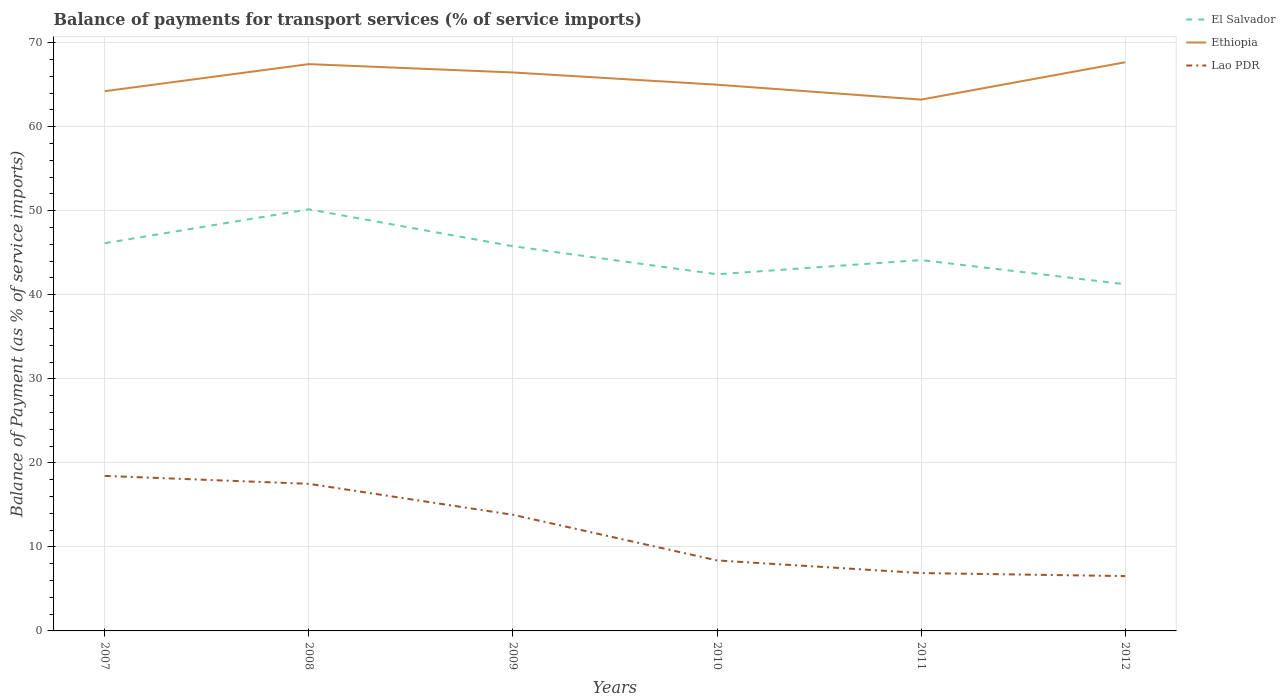How many different coloured lines are there?
Keep it short and to the point. 3. Is the number of lines equal to the number of legend labels?
Your answer should be compact. Yes. Across all years, what is the maximum balance of payments for transport services in Ethiopia?
Ensure brevity in your answer.  63.23. In which year was the balance of payments for transport services in El Salvador maximum?
Your response must be concise. 2012. What is the total balance of payments for transport services in Ethiopia in the graph?
Your answer should be compact. -3.22. What is the difference between the highest and the second highest balance of payments for transport services in Lao PDR?
Provide a succinct answer. 11.92. What is the difference between the highest and the lowest balance of payments for transport services in Lao PDR?
Your response must be concise. 3. How many years are there in the graph?
Your answer should be very brief. 6. Are the values on the major ticks of Y-axis written in scientific E-notation?
Make the answer very short. No. Does the graph contain any zero values?
Keep it short and to the point. No. What is the title of the graph?
Give a very brief answer. Balance of payments for transport services (% of service imports). What is the label or title of the Y-axis?
Provide a succinct answer. Balance of Payment (as % of service imports). What is the Balance of Payment (as % of service imports) in El Salvador in 2007?
Make the answer very short. 46.14. What is the Balance of Payment (as % of service imports) of Ethiopia in 2007?
Give a very brief answer. 64.23. What is the Balance of Payment (as % of service imports) of Lao PDR in 2007?
Give a very brief answer. 18.45. What is the Balance of Payment (as % of service imports) in El Salvador in 2008?
Provide a short and direct response. 50.17. What is the Balance of Payment (as % of service imports) of Ethiopia in 2008?
Your response must be concise. 67.45. What is the Balance of Payment (as % of service imports) in Lao PDR in 2008?
Your answer should be compact. 17.51. What is the Balance of Payment (as % of service imports) in El Salvador in 2009?
Give a very brief answer. 45.78. What is the Balance of Payment (as % of service imports) of Ethiopia in 2009?
Make the answer very short. 66.46. What is the Balance of Payment (as % of service imports) of Lao PDR in 2009?
Your answer should be very brief. 13.82. What is the Balance of Payment (as % of service imports) in El Salvador in 2010?
Keep it short and to the point. 42.44. What is the Balance of Payment (as % of service imports) of Ethiopia in 2010?
Provide a short and direct response. 65. What is the Balance of Payment (as % of service imports) in Lao PDR in 2010?
Your answer should be very brief. 8.39. What is the Balance of Payment (as % of service imports) of El Salvador in 2011?
Your answer should be very brief. 44.13. What is the Balance of Payment (as % of service imports) of Ethiopia in 2011?
Make the answer very short. 63.23. What is the Balance of Payment (as % of service imports) in Lao PDR in 2011?
Your answer should be compact. 6.89. What is the Balance of Payment (as % of service imports) in El Salvador in 2012?
Ensure brevity in your answer.  41.25. What is the Balance of Payment (as % of service imports) of Ethiopia in 2012?
Give a very brief answer. 67.67. What is the Balance of Payment (as % of service imports) of Lao PDR in 2012?
Offer a very short reply. 6.53. Across all years, what is the maximum Balance of Payment (as % of service imports) in El Salvador?
Ensure brevity in your answer.  50.17. Across all years, what is the maximum Balance of Payment (as % of service imports) in Ethiopia?
Make the answer very short. 67.67. Across all years, what is the maximum Balance of Payment (as % of service imports) in Lao PDR?
Make the answer very short. 18.45. Across all years, what is the minimum Balance of Payment (as % of service imports) in El Salvador?
Ensure brevity in your answer.  41.25. Across all years, what is the minimum Balance of Payment (as % of service imports) of Ethiopia?
Keep it short and to the point. 63.23. Across all years, what is the minimum Balance of Payment (as % of service imports) in Lao PDR?
Your response must be concise. 6.53. What is the total Balance of Payment (as % of service imports) in El Salvador in the graph?
Your answer should be compact. 269.92. What is the total Balance of Payment (as % of service imports) in Ethiopia in the graph?
Your answer should be compact. 394.03. What is the total Balance of Payment (as % of service imports) in Lao PDR in the graph?
Your answer should be compact. 71.57. What is the difference between the Balance of Payment (as % of service imports) in El Salvador in 2007 and that in 2008?
Ensure brevity in your answer.  -4.03. What is the difference between the Balance of Payment (as % of service imports) in Ethiopia in 2007 and that in 2008?
Make the answer very short. -3.22. What is the difference between the Balance of Payment (as % of service imports) of Lao PDR in 2007 and that in 2008?
Keep it short and to the point. 0.94. What is the difference between the Balance of Payment (as % of service imports) in El Salvador in 2007 and that in 2009?
Keep it short and to the point. 0.36. What is the difference between the Balance of Payment (as % of service imports) of Ethiopia in 2007 and that in 2009?
Provide a succinct answer. -2.23. What is the difference between the Balance of Payment (as % of service imports) in Lao PDR in 2007 and that in 2009?
Your response must be concise. 4.63. What is the difference between the Balance of Payment (as % of service imports) of El Salvador in 2007 and that in 2010?
Offer a very short reply. 3.69. What is the difference between the Balance of Payment (as % of service imports) of Ethiopia in 2007 and that in 2010?
Your response must be concise. -0.77. What is the difference between the Balance of Payment (as % of service imports) in Lao PDR in 2007 and that in 2010?
Keep it short and to the point. 10.06. What is the difference between the Balance of Payment (as % of service imports) in El Salvador in 2007 and that in 2011?
Keep it short and to the point. 2.01. What is the difference between the Balance of Payment (as % of service imports) in Lao PDR in 2007 and that in 2011?
Your response must be concise. 11.56. What is the difference between the Balance of Payment (as % of service imports) of El Salvador in 2007 and that in 2012?
Your response must be concise. 4.88. What is the difference between the Balance of Payment (as % of service imports) in Ethiopia in 2007 and that in 2012?
Your response must be concise. -3.44. What is the difference between the Balance of Payment (as % of service imports) of Lao PDR in 2007 and that in 2012?
Provide a short and direct response. 11.92. What is the difference between the Balance of Payment (as % of service imports) in El Salvador in 2008 and that in 2009?
Provide a short and direct response. 4.39. What is the difference between the Balance of Payment (as % of service imports) of Lao PDR in 2008 and that in 2009?
Ensure brevity in your answer.  3.69. What is the difference between the Balance of Payment (as % of service imports) in El Salvador in 2008 and that in 2010?
Offer a very short reply. 7.73. What is the difference between the Balance of Payment (as % of service imports) in Ethiopia in 2008 and that in 2010?
Offer a terse response. 2.45. What is the difference between the Balance of Payment (as % of service imports) of Lao PDR in 2008 and that in 2010?
Offer a very short reply. 9.12. What is the difference between the Balance of Payment (as % of service imports) of El Salvador in 2008 and that in 2011?
Offer a very short reply. 6.04. What is the difference between the Balance of Payment (as % of service imports) of Ethiopia in 2008 and that in 2011?
Offer a terse response. 4.22. What is the difference between the Balance of Payment (as % of service imports) of Lao PDR in 2008 and that in 2011?
Your answer should be compact. 10.62. What is the difference between the Balance of Payment (as % of service imports) of El Salvador in 2008 and that in 2012?
Offer a very short reply. 8.92. What is the difference between the Balance of Payment (as % of service imports) of Ethiopia in 2008 and that in 2012?
Make the answer very short. -0.22. What is the difference between the Balance of Payment (as % of service imports) in Lao PDR in 2008 and that in 2012?
Your answer should be very brief. 10.98. What is the difference between the Balance of Payment (as % of service imports) in El Salvador in 2009 and that in 2010?
Offer a very short reply. 3.33. What is the difference between the Balance of Payment (as % of service imports) of Ethiopia in 2009 and that in 2010?
Ensure brevity in your answer.  1.46. What is the difference between the Balance of Payment (as % of service imports) of Lao PDR in 2009 and that in 2010?
Keep it short and to the point. 5.43. What is the difference between the Balance of Payment (as % of service imports) in El Salvador in 2009 and that in 2011?
Keep it short and to the point. 1.65. What is the difference between the Balance of Payment (as % of service imports) in Ethiopia in 2009 and that in 2011?
Provide a succinct answer. 3.23. What is the difference between the Balance of Payment (as % of service imports) in Lao PDR in 2009 and that in 2011?
Your answer should be very brief. 6.93. What is the difference between the Balance of Payment (as % of service imports) of El Salvador in 2009 and that in 2012?
Your response must be concise. 4.53. What is the difference between the Balance of Payment (as % of service imports) of Ethiopia in 2009 and that in 2012?
Make the answer very short. -1.21. What is the difference between the Balance of Payment (as % of service imports) of Lao PDR in 2009 and that in 2012?
Ensure brevity in your answer.  7.29. What is the difference between the Balance of Payment (as % of service imports) of El Salvador in 2010 and that in 2011?
Ensure brevity in your answer.  -1.69. What is the difference between the Balance of Payment (as % of service imports) in Ethiopia in 2010 and that in 2011?
Make the answer very short. 1.77. What is the difference between the Balance of Payment (as % of service imports) of Lao PDR in 2010 and that in 2011?
Offer a very short reply. 1.5. What is the difference between the Balance of Payment (as % of service imports) in El Salvador in 2010 and that in 2012?
Your response must be concise. 1.19. What is the difference between the Balance of Payment (as % of service imports) of Ethiopia in 2010 and that in 2012?
Offer a terse response. -2.67. What is the difference between the Balance of Payment (as % of service imports) of Lao PDR in 2010 and that in 2012?
Offer a very short reply. 1.86. What is the difference between the Balance of Payment (as % of service imports) of El Salvador in 2011 and that in 2012?
Give a very brief answer. 2.88. What is the difference between the Balance of Payment (as % of service imports) in Ethiopia in 2011 and that in 2012?
Keep it short and to the point. -4.44. What is the difference between the Balance of Payment (as % of service imports) of Lao PDR in 2011 and that in 2012?
Make the answer very short. 0.36. What is the difference between the Balance of Payment (as % of service imports) of El Salvador in 2007 and the Balance of Payment (as % of service imports) of Ethiopia in 2008?
Give a very brief answer. -21.31. What is the difference between the Balance of Payment (as % of service imports) in El Salvador in 2007 and the Balance of Payment (as % of service imports) in Lao PDR in 2008?
Make the answer very short. 28.63. What is the difference between the Balance of Payment (as % of service imports) of Ethiopia in 2007 and the Balance of Payment (as % of service imports) of Lao PDR in 2008?
Keep it short and to the point. 46.73. What is the difference between the Balance of Payment (as % of service imports) in El Salvador in 2007 and the Balance of Payment (as % of service imports) in Ethiopia in 2009?
Give a very brief answer. -20.32. What is the difference between the Balance of Payment (as % of service imports) in El Salvador in 2007 and the Balance of Payment (as % of service imports) in Lao PDR in 2009?
Your response must be concise. 32.32. What is the difference between the Balance of Payment (as % of service imports) of Ethiopia in 2007 and the Balance of Payment (as % of service imports) of Lao PDR in 2009?
Keep it short and to the point. 50.41. What is the difference between the Balance of Payment (as % of service imports) of El Salvador in 2007 and the Balance of Payment (as % of service imports) of Ethiopia in 2010?
Give a very brief answer. -18.86. What is the difference between the Balance of Payment (as % of service imports) in El Salvador in 2007 and the Balance of Payment (as % of service imports) in Lao PDR in 2010?
Provide a short and direct response. 37.75. What is the difference between the Balance of Payment (as % of service imports) in Ethiopia in 2007 and the Balance of Payment (as % of service imports) in Lao PDR in 2010?
Your response must be concise. 55.84. What is the difference between the Balance of Payment (as % of service imports) of El Salvador in 2007 and the Balance of Payment (as % of service imports) of Ethiopia in 2011?
Keep it short and to the point. -17.09. What is the difference between the Balance of Payment (as % of service imports) of El Salvador in 2007 and the Balance of Payment (as % of service imports) of Lao PDR in 2011?
Ensure brevity in your answer.  39.25. What is the difference between the Balance of Payment (as % of service imports) in Ethiopia in 2007 and the Balance of Payment (as % of service imports) in Lao PDR in 2011?
Your response must be concise. 57.34. What is the difference between the Balance of Payment (as % of service imports) in El Salvador in 2007 and the Balance of Payment (as % of service imports) in Ethiopia in 2012?
Provide a succinct answer. -21.53. What is the difference between the Balance of Payment (as % of service imports) of El Salvador in 2007 and the Balance of Payment (as % of service imports) of Lao PDR in 2012?
Keep it short and to the point. 39.61. What is the difference between the Balance of Payment (as % of service imports) of Ethiopia in 2007 and the Balance of Payment (as % of service imports) of Lao PDR in 2012?
Your answer should be compact. 57.7. What is the difference between the Balance of Payment (as % of service imports) of El Salvador in 2008 and the Balance of Payment (as % of service imports) of Ethiopia in 2009?
Your answer should be very brief. -16.29. What is the difference between the Balance of Payment (as % of service imports) in El Salvador in 2008 and the Balance of Payment (as % of service imports) in Lao PDR in 2009?
Give a very brief answer. 36.35. What is the difference between the Balance of Payment (as % of service imports) in Ethiopia in 2008 and the Balance of Payment (as % of service imports) in Lao PDR in 2009?
Your answer should be very brief. 53.63. What is the difference between the Balance of Payment (as % of service imports) in El Salvador in 2008 and the Balance of Payment (as % of service imports) in Ethiopia in 2010?
Keep it short and to the point. -14.83. What is the difference between the Balance of Payment (as % of service imports) in El Salvador in 2008 and the Balance of Payment (as % of service imports) in Lao PDR in 2010?
Your response must be concise. 41.78. What is the difference between the Balance of Payment (as % of service imports) in Ethiopia in 2008 and the Balance of Payment (as % of service imports) in Lao PDR in 2010?
Your response must be concise. 59.06. What is the difference between the Balance of Payment (as % of service imports) of El Salvador in 2008 and the Balance of Payment (as % of service imports) of Ethiopia in 2011?
Your answer should be compact. -13.05. What is the difference between the Balance of Payment (as % of service imports) of El Salvador in 2008 and the Balance of Payment (as % of service imports) of Lao PDR in 2011?
Ensure brevity in your answer.  43.29. What is the difference between the Balance of Payment (as % of service imports) of Ethiopia in 2008 and the Balance of Payment (as % of service imports) of Lao PDR in 2011?
Offer a terse response. 60.56. What is the difference between the Balance of Payment (as % of service imports) of El Salvador in 2008 and the Balance of Payment (as % of service imports) of Ethiopia in 2012?
Provide a succinct answer. -17.5. What is the difference between the Balance of Payment (as % of service imports) of El Salvador in 2008 and the Balance of Payment (as % of service imports) of Lao PDR in 2012?
Offer a terse response. 43.65. What is the difference between the Balance of Payment (as % of service imports) of Ethiopia in 2008 and the Balance of Payment (as % of service imports) of Lao PDR in 2012?
Your answer should be very brief. 60.92. What is the difference between the Balance of Payment (as % of service imports) in El Salvador in 2009 and the Balance of Payment (as % of service imports) in Ethiopia in 2010?
Your response must be concise. -19.22. What is the difference between the Balance of Payment (as % of service imports) in El Salvador in 2009 and the Balance of Payment (as % of service imports) in Lao PDR in 2010?
Make the answer very short. 37.39. What is the difference between the Balance of Payment (as % of service imports) in Ethiopia in 2009 and the Balance of Payment (as % of service imports) in Lao PDR in 2010?
Provide a short and direct response. 58.07. What is the difference between the Balance of Payment (as % of service imports) of El Salvador in 2009 and the Balance of Payment (as % of service imports) of Ethiopia in 2011?
Ensure brevity in your answer.  -17.45. What is the difference between the Balance of Payment (as % of service imports) in El Salvador in 2009 and the Balance of Payment (as % of service imports) in Lao PDR in 2011?
Ensure brevity in your answer.  38.89. What is the difference between the Balance of Payment (as % of service imports) of Ethiopia in 2009 and the Balance of Payment (as % of service imports) of Lao PDR in 2011?
Your answer should be compact. 59.57. What is the difference between the Balance of Payment (as % of service imports) in El Salvador in 2009 and the Balance of Payment (as % of service imports) in Ethiopia in 2012?
Keep it short and to the point. -21.89. What is the difference between the Balance of Payment (as % of service imports) in El Salvador in 2009 and the Balance of Payment (as % of service imports) in Lao PDR in 2012?
Ensure brevity in your answer.  39.25. What is the difference between the Balance of Payment (as % of service imports) of Ethiopia in 2009 and the Balance of Payment (as % of service imports) of Lao PDR in 2012?
Ensure brevity in your answer.  59.93. What is the difference between the Balance of Payment (as % of service imports) of El Salvador in 2010 and the Balance of Payment (as % of service imports) of Ethiopia in 2011?
Offer a very short reply. -20.78. What is the difference between the Balance of Payment (as % of service imports) of El Salvador in 2010 and the Balance of Payment (as % of service imports) of Lao PDR in 2011?
Keep it short and to the point. 35.56. What is the difference between the Balance of Payment (as % of service imports) in Ethiopia in 2010 and the Balance of Payment (as % of service imports) in Lao PDR in 2011?
Give a very brief answer. 58.11. What is the difference between the Balance of Payment (as % of service imports) in El Salvador in 2010 and the Balance of Payment (as % of service imports) in Ethiopia in 2012?
Offer a very short reply. -25.23. What is the difference between the Balance of Payment (as % of service imports) of El Salvador in 2010 and the Balance of Payment (as % of service imports) of Lao PDR in 2012?
Your answer should be compact. 35.92. What is the difference between the Balance of Payment (as % of service imports) in Ethiopia in 2010 and the Balance of Payment (as % of service imports) in Lao PDR in 2012?
Offer a very short reply. 58.48. What is the difference between the Balance of Payment (as % of service imports) of El Salvador in 2011 and the Balance of Payment (as % of service imports) of Ethiopia in 2012?
Offer a very short reply. -23.54. What is the difference between the Balance of Payment (as % of service imports) of El Salvador in 2011 and the Balance of Payment (as % of service imports) of Lao PDR in 2012?
Offer a very short reply. 37.61. What is the difference between the Balance of Payment (as % of service imports) in Ethiopia in 2011 and the Balance of Payment (as % of service imports) in Lao PDR in 2012?
Give a very brief answer. 56.7. What is the average Balance of Payment (as % of service imports) of El Salvador per year?
Ensure brevity in your answer.  44.99. What is the average Balance of Payment (as % of service imports) in Ethiopia per year?
Provide a short and direct response. 65.67. What is the average Balance of Payment (as % of service imports) in Lao PDR per year?
Offer a very short reply. 11.93. In the year 2007, what is the difference between the Balance of Payment (as % of service imports) of El Salvador and Balance of Payment (as % of service imports) of Ethiopia?
Offer a terse response. -18.09. In the year 2007, what is the difference between the Balance of Payment (as % of service imports) in El Salvador and Balance of Payment (as % of service imports) in Lao PDR?
Your answer should be very brief. 27.69. In the year 2007, what is the difference between the Balance of Payment (as % of service imports) of Ethiopia and Balance of Payment (as % of service imports) of Lao PDR?
Your response must be concise. 45.78. In the year 2008, what is the difference between the Balance of Payment (as % of service imports) in El Salvador and Balance of Payment (as % of service imports) in Ethiopia?
Provide a short and direct response. -17.28. In the year 2008, what is the difference between the Balance of Payment (as % of service imports) of El Salvador and Balance of Payment (as % of service imports) of Lao PDR?
Your answer should be very brief. 32.67. In the year 2008, what is the difference between the Balance of Payment (as % of service imports) of Ethiopia and Balance of Payment (as % of service imports) of Lao PDR?
Your answer should be very brief. 49.94. In the year 2009, what is the difference between the Balance of Payment (as % of service imports) in El Salvador and Balance of Payment (as % of service imports) in Ethiopia?
Offer a terse response. -20.68. In the year 2009, what is the difference between the Balance of Payment (as % of service imports) of El Salvador and Balance of Payment (as % of service imports) of Lao PDR?
Your response must be concise. 31.96. In the year 2009, what is the difference between the Balance of Payment (as % of service imports) of Ethiopia and Balance of Payment (as % of service imports) of Lao PDR?
Offer a very short reply. 52.64. In the year 2010, what is the difference between the Balance of Payment (as % of service imports) in El Salvador and Balance of Payment (as % of service imports) in Ethiopia?
Your response must be concise. -22.56. In the year 2010, what is the difference between the Balance of Payment (as % of service imports) of El Salvador and Balance of Payment (as % of service imports) of Lao PDR?
Offer a terse response. 34.06. In the year 2010, what is the difference between the Balance of Payment (as % of service imports) in Ethiopia and Balance of Payment (as % of service imports) in Lao PDR?
Provide a succinct answer. 56.61. In the year 2011, what is the difference between the Balance of Payment (as % of service imports) of El Salvador and Balance of Payment (as % of service imports) of Ethiopia?
Ensure brevity in your answer.  -19.09. In the year 2011, what is the difference between the Balance of Payment (as % of service imports) in El Salvador and Balance of Payment (as % of service imports) in Lao PDR?
Your response must be concise. 37.25. In the year 2011, what is the difference between the Balance of Payment (as % of service imports) of Ethiopia and Balance of Payment (as % of service imports) of Lao PDR?
Give a very brief answer. 56.34. In the year 2012, what is the difference between the Balance of Payment (as % of service imports) in El Salvador and Balance of Payment (as % of service imports) in Ethiopia?
Offer a terse response. -26.42. In the year 2012, what is the difference between the Balance of Payment (as % of service imports) in El Salvador and Balance of Payment (as % of service imports) in Lao PDR?
Your response must be concise. 34.73. In the year 2012, what is the difference between the Balance of Payment (as % of service imports) in Ethiopia and Balance of Payment (as % of service imports) in Lao PDR?
Keep it short and to the point. 61.14. What is the ratio of the Balance of Payment (as % of service imports) of El Salvador in 2007 to that in 2008?
Offer a terse response. 0.92. What is the ratio of the Balance of Payment (as % of service imports) in Ethiopia in 2007 to that in 2008?
Give a very brief answer. 0.95. What is the ratio of the Balance of Payment (as % of service imports) of Lao PDR in 2007 to that in 2008?
Your answer should be very brief. 1.05. What is the ratio of the Balance of Payment (as % of service imports) in Ethiopia in 2007 to that in 2009?
Make the answer very short. 0.97. What is the ratio of the Balance of Payment (as % of service imports) of Lao PDR in 2007 to that in 2009?
Make the answer very short. 1.33. What is the ratio of the Balance of Payment (as % of service imports) in El Salvador in 2007 to that in 2010?
Offer a very short reply. 1.09. What is the ratio of the Balance of Payment (as % of service imports) of Ethiopia in 2007 to that in 2010?
Keep it short and to the point. 0.99. What is the ratio of the Balance of Payment (as % of service imports) of Lao PDR in 2007 to that in 2010?
Your answer should be very brief. 2.2. What is the ratio of the Balance of Payment (as % of service imports) in El Salvador in 2007 to that in 2011?
Offer a terse response. 1.05. What is the ratio of the Balance of Payment (as % of service imports) of Ethiopia in 2007 to that in 2011?
Provide a short and direct response. 1.02. What is the ratio of the Balance of Payment (as % of service imports) of Lao PDR in 2007 to that in 2011?
Provide a short and direct response. 2.68. What is the ratio of the Balance of Payment (as % of service imports) in El Salvador in 2007 to that in 2012?
Provide a short and direct response. 1.12. What is the ratio of the Balance of Payment (as % of service imports) in Ethiopia in 2007 to that in 2012?
Provide a short and direct response. 0.95. What is the ratio of the Balance of Payment (as % of service imports) in Lao PDR in 2007 to that in 2012?
Make the answer very short. 2.83. What is the ratio of the Balance of Payment (as % of service imports) of El Salvador in 2008 to that in 2009?
Ensure brevity in your answer.  1.1. What is the ratio of the Balance of Payment (as % of service imports) in Ethiopia in 2008 to that in 2009?
Give a very brief answer. 1.01. What is the ratio of the Balance of Payment (as % of service imports) of Lao PDR in 2008 to that in 2009?
Offer a terse response. 1.27. What is the ratio of the Balance of Payment (as % of service imports) of El Salvador in 2008 to that in 2010?
Offer a very short reply. 1.18. What is the ratio of the Balance of Payment (as % of service imports) in Ethiopia in 2008 to that in 2010?
Provide a short and direct response. 1.04. What is the ratio of the Balance of Payment (as % of service imports) of Lao PDR in 2008 to that in 2010?
Your response must be concise. 2.09. What is the ratio of the Balance of Payment (as % of service imports) in El Salvador in 2008 to that in 2011?
Your answer should be very brief. 1.14. What is the ratio of the Balance of Payment (as % of service imports) in Ethiopia in 2008 to that in 2011?
Give a very brief answer. 1.07. What is the ratio of the Balance of Payment (as % of service imports) of Lao PDR in 2008 to that in 2011?
Your response must be concise. 2.54. What is the ratio of the Balance of Payment (as % of service imports) of El Salvador in 2008 to that in 2012?
Provide a short and direct response. 1.22. What is the ratio of the Balance of Payment (as % of service imports) of Ethiopia in 2008 to that in 2012?
Ensure brevity in your answer.  1. What is the ratio of the Balance of Payment (as % of service imports) in Lao PDR in 2008 to that in 2012?
Your answer should be compact. 2.68. What is the ratio of the Balance of Payment (as % of service imports) in El Salvador in 2009 to that in 2010?
Make the answer very short. 1.08. What is the ratio of the Balance of Payment (as % of service imports) in Ethiopia in 2009 to that in 2010?
Offer a terse response. 1.02. What is the ratio of the Balance of Payment (as % of service imports) of Lao PDR in 2009 to that in 2010?
Your response must be concise. 1.65. What is the ratio of the Balance of Payment (as % of service imports) of El Salvador in 2009 to that in 2011?
Offer a terse response. 1.04. What is the ratio of the Balance of Payment (as % of service imports) in Ethiopia in 2009 to that in 2011?
Ensure brevity in your answer.  1.05. What is the ratio of the Balance of Payment (as % of service imports) of Lao PDR in 2009 to that in 2011?
Your response must be concise. 2.01. What is the ratio of the Balance of Payment (as % of service imports) in El Salvador in 2009 to that in 2012?
Give a very brief answer. 1.11. What is the ratio of the Balance of Payment (as % of service imports) of Ethiopia in 2009 to that in 2012?
Ensure brevity in your answer.  0.98. What is the ratio of the Balance of Payment (as % of service imports) of Lao PDR in 2009 to that in 2012?
Make the answer very short. 2.12. What is the ratio of the Balance of Payment (as % of service imports) of El Salvador in 2010 to that in 2011?
Offer a very short reply. 0.96. What is the ratio of the Balance of Payment (as % of service imports) in Ethiopia in 2010 to that in 2011?
Provide a short and direct response. 1.03. What is the ratio of the Balance of Payment (as % of service imports) in Lao PDR in 2010 to that in 2011?
Offer a very short reply. 1.22. What is the ratio of the Balance of Payment (as % of service imports) of El Salvador in 2010 to that in 2012?
Your answer should be very brief. 1.03. What is the ratio of the Balance of Payment (as % of service imports) of Ethiopia in 2010 to that in 2012?
Your answer should be compact. 0.96. What is the ratio of the Balance of Payment (as % of service imports) in Lao PDR in 2010 to that in 2012?
Your response must be concise. 1.29. What is the ratio of the Balance of Payment (as % of service imports) of El Salvador in 2011 to that in 2012?
Your response must be concise. 1.07. What is the ratio of the Balance of Payment (as % of service imports) in Ethiopia in 2011 to that in 2012?
Provide a succinct answer. 0.93. What is the ratio of the Balance of Payment (as % of service imports) of Lao PDR in 2011 to that in 2012?
Make the answer very short. 1.06. What is the difference between the highest and the second highest Balance of Payment (as % of service imports) of El Salvador?
Provide a short and direct response. 4.03. What is the difference between the highest and the second highest Balance of Payment (as % of service imports) of Ethiopia?
Keep it short and to the point. 0.22. What is the difference between the highest and the second highest Balance of Payment (as % of service imports) in Lao PDR?
Provide a short and direct response. 0.94. What is the difference between the highest and the lowest Balance of Payment (as % of service imports) of El Salvador?
Ensure brevity in your answer.  8.92. What is the difference between the highest and the lowest Balance of Payment (as % of service imports) in Ethiopia?
Provide a short and direct response. 4.44. What is the difference between the highest and the lowest Balance of Payment (as % of service imports) of Lao PDR?
Provide a short and direct response. 11.92. 